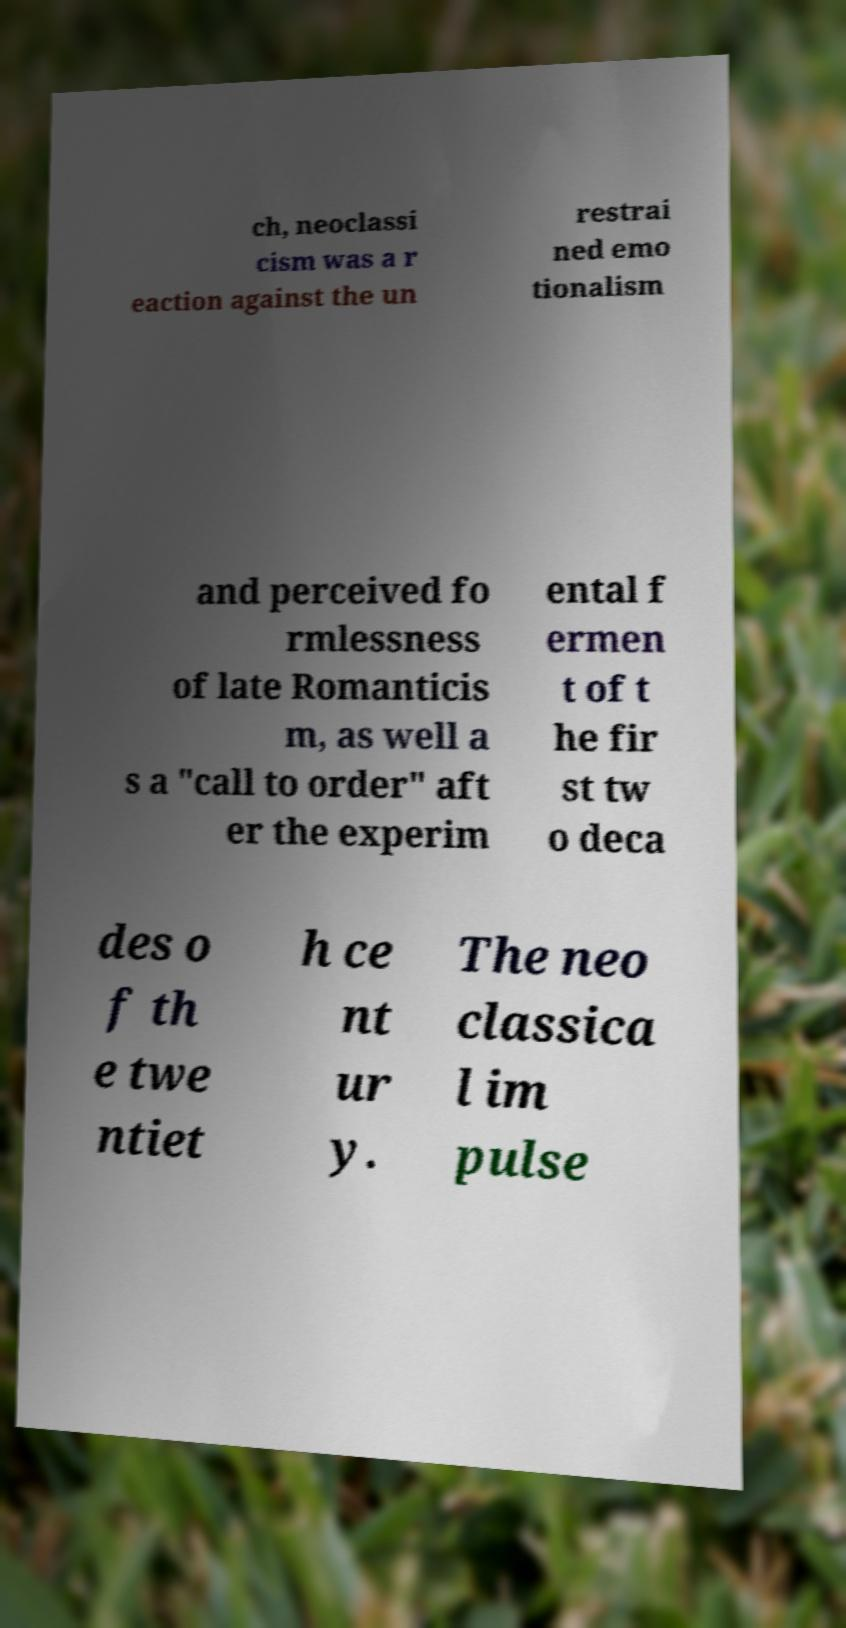There's text embedded in this image that I need extracted. Can you transcribe it verbatim? ch, neoclassi cism was a r eaction against the un restrai ned emo tionalism and perceived fo rmlessness of late Romanticis m, as well a s a "call to order" aft er the experim ental f ermen t of t he fir st tw o deca des o f th e twe ntiet h ce nt ur y. The neo classica l im pulse 